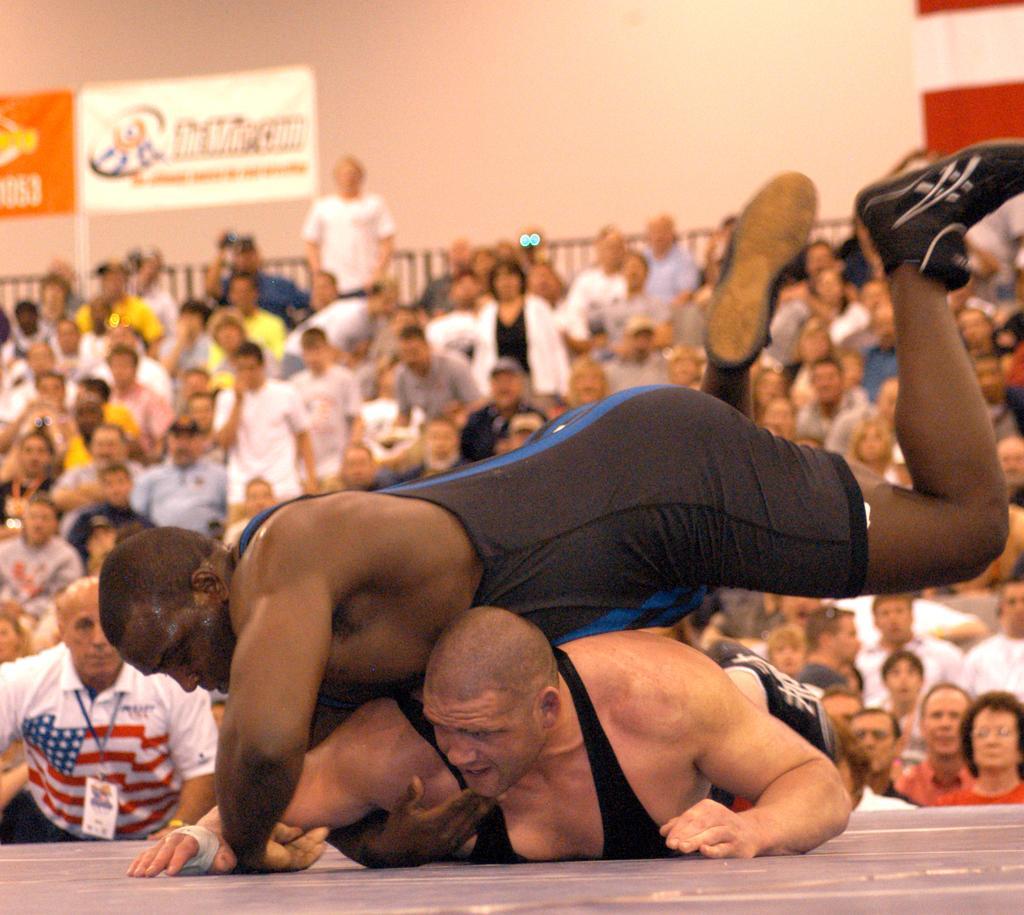Please provide a concise description of this image. In this picture I can observe two men fighting in the middle of the picture. In the background there are some people and I can observe wall. 